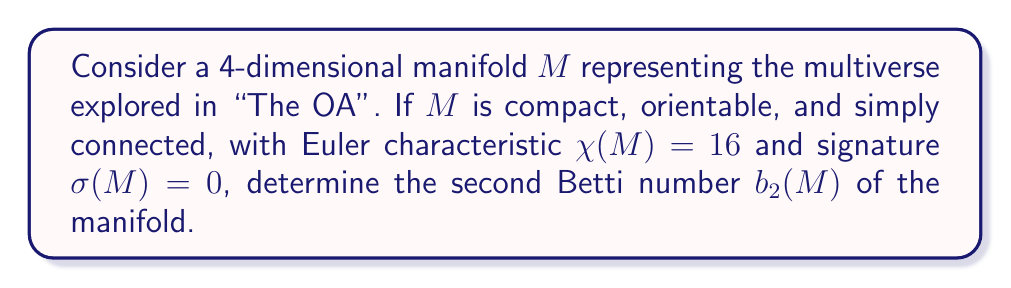Can you answer this question? To solve this problem, we'll use the properties of 4-dimensional manifolds and the given information:

1) For a 4-dimensional manifold, the Betti numbers are related to the Euler characteristic by:
   $$\chi(M) = 2 - 2b_1 + b_2 + 2b_3 - b_4$$

2) Since $M$ is simply connected, $b_1 = 0$.

3) By Poincaré duality for a closed, orientable 4-manifold:
   $b_0 = b_4 = 1$ and $b_1 = b_3$

4) The signature of a 4-manifold is given by:
   $$\sigma(M) = b_2^+ - b_2^-$$
   where $b_2 = b_2^+ + b_2^-$

5) Given $\sigma(M) = 0$, we have $b_2^+ = b_2^-$, so $b_2 = 2b_2^+$

Now, let's substitute these into the Euler characteristic equation:

$$16 = 2 - 2(0) + b_2 + 2(0) - 1$$
$$16 = 1 + b_2$$
$$b_2 = 15$$

To verify, we can check that this satisfies the signature condition:
$b_2 = 15 = 2b_2^+$, so $b_2^+ = \frac{15}{2}$, which is consistent with $b_2^+ = b_2^-$.

Therefore, the second Betti number $b_2(M) = 15$.
Answer: $b_2(M) = 15$ 